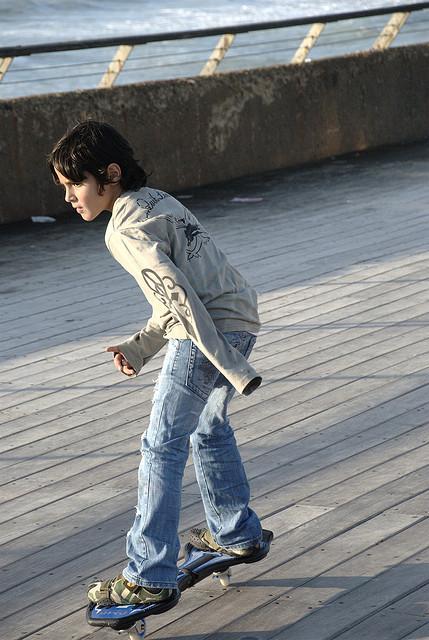Is the skateboarder an adult man or a young boy?
Answer briefly. Young boy. Are the boys shoes in disrepair?
Concise answer only. Yes. Is the kid on the roller skate good at skating?
Quick response, please. Yes. 